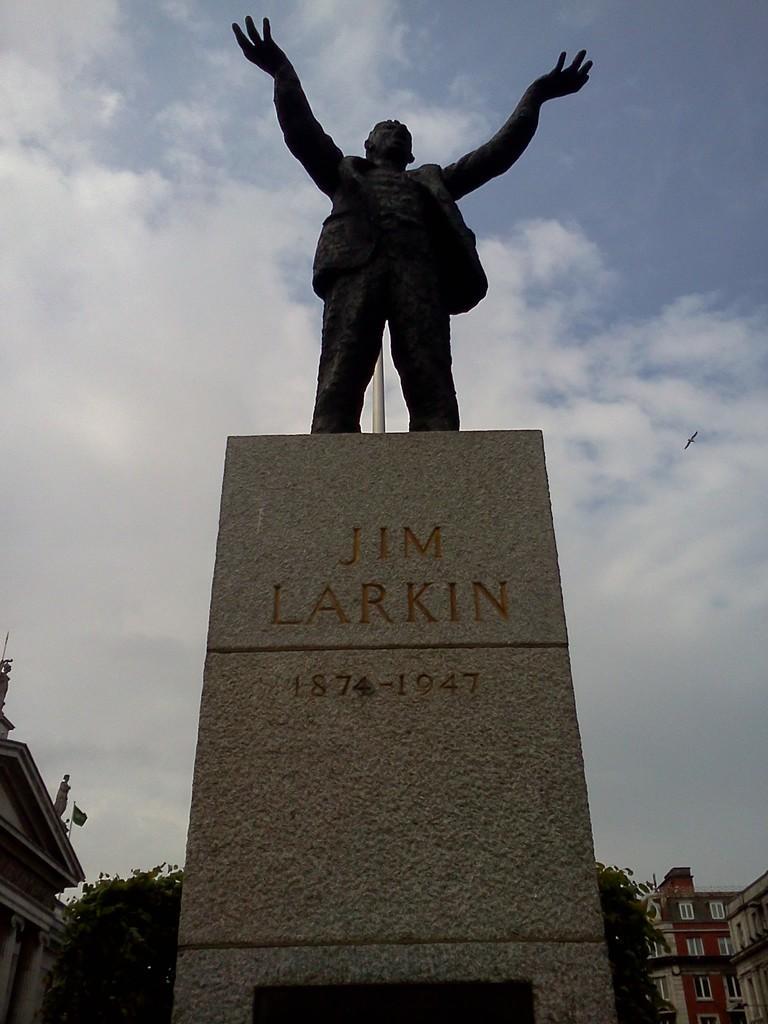Could you give a brief overview of what you see in this image? A statue is highlighted in this picture. The statue is in black color. This statue name is "Jim Larkin". Sky is cloudy. Far there are trees. Far there is a building with windows. 